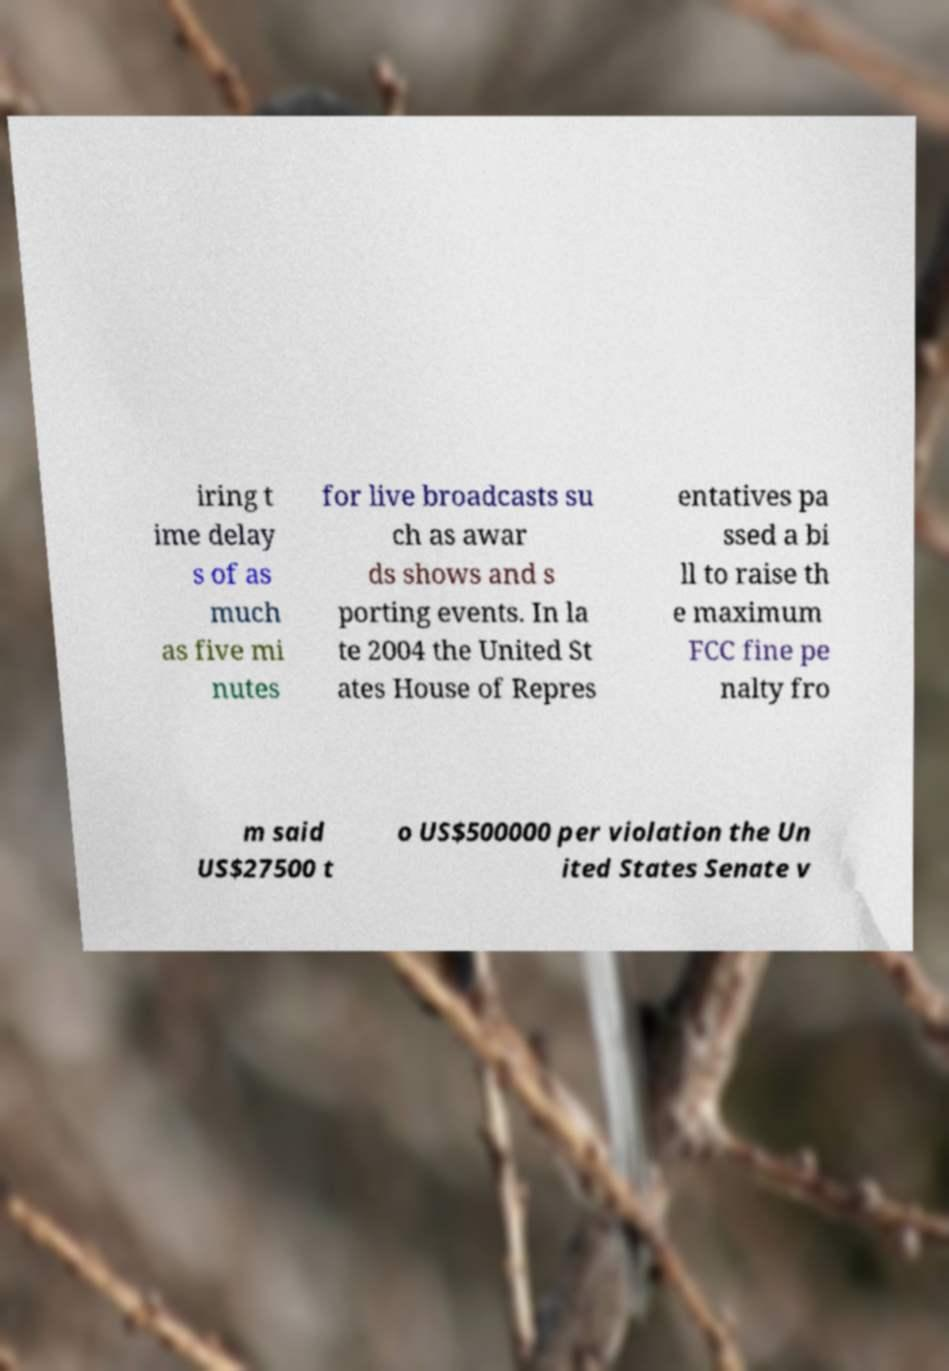For documentation purposes, I need the text within this image transcribed. Could you provide that? iring t ime delay s of as much as five mi nutes for live broadcasts su ch as awar ds shows and s porting events. In la te 2004 the United St ates House of Repres entatives pa ssed a bi ll to raise th e maximum FCC fine pe nalty fro m said US$27500 t o US$500000 per violation the Un ited States Senate v 